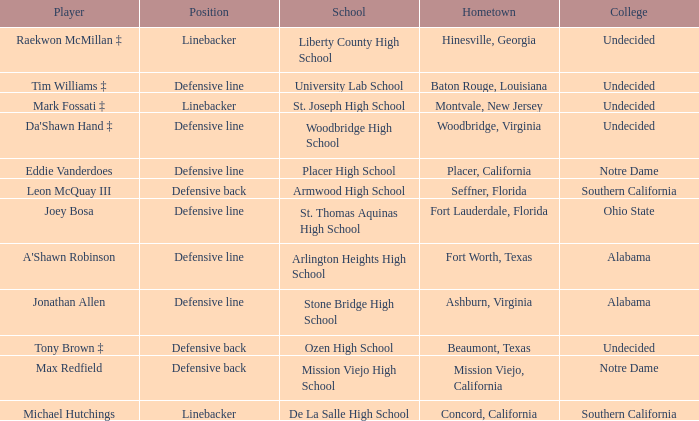What is the position of the player from Fort Lauderdale, Florida? Defensive line. 